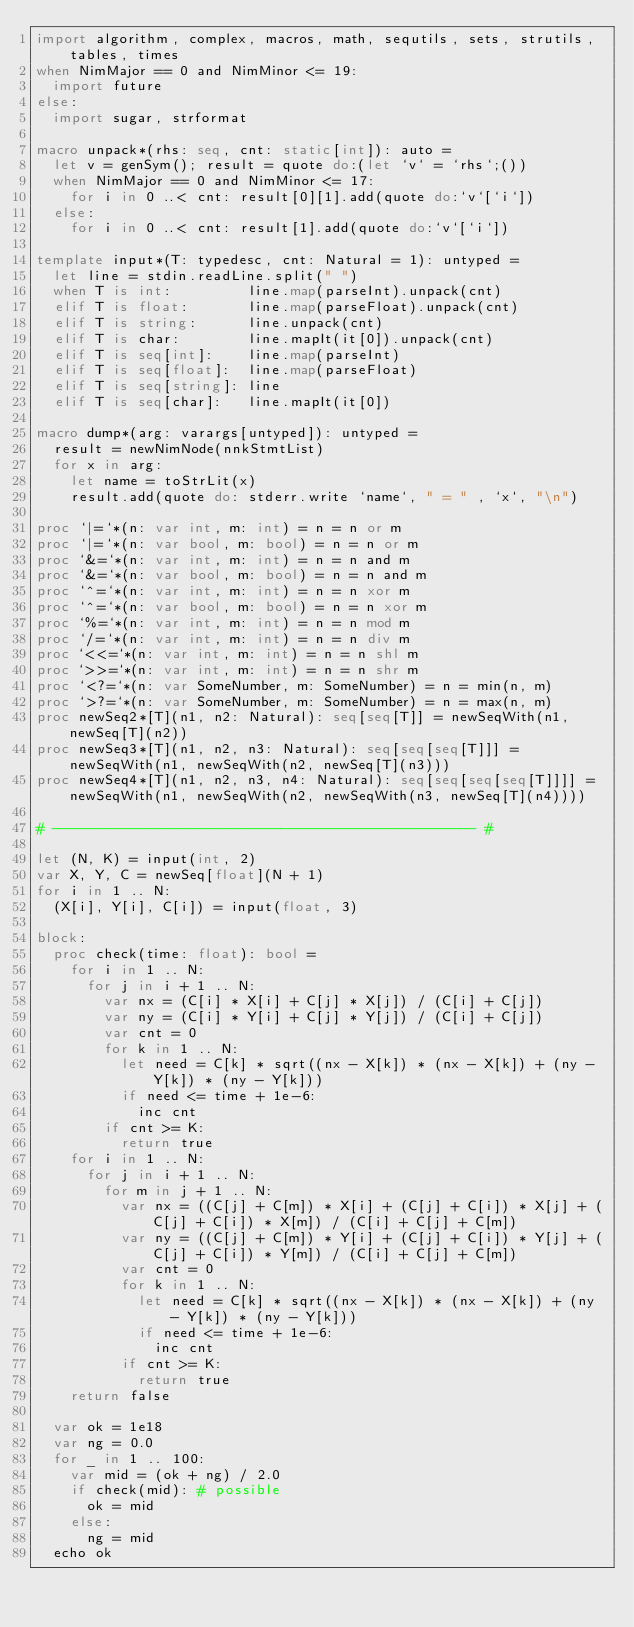Convert code to text. <code><loc_0><loc_0><loc_500><loc_500><_Nim_>import algorithm, complex, macros, math, sequtils, sets, strutils, tables, times
when NimMajor == 0 and NimMinor <= 19:
  import future
else:
  import sugar, strformat

macro unpack*(rhs: seq, cnt: static[int]): auto =
  let v = genSym(); result = quote do:(let `v` = `rhs`;())
  when NimMajor == 0 and NimMinor <= 17:
    for i in 0 ..< cnt: result[0][1].add(quote do:`v`[`i`])
  else:
    for i in 0 ..< cnt: result[1].add(quote do:`v`[`i`])

template input*(T: typedesc, cnt: Natural = 1): untyped =
  let line = stdin.readLine.split(" ")
  when T is int:         line.map(parseInt).unpack(cnt)
  elif T is float:       line.map(parseFloat).unpack(cnt)
  elif T is string:      line.unpack(cnt)
  elif T is char:        line.mapIt(it[0]).unpack(cnt)
  elif T is seq[int]:    line.map(parseInt)
  elif T is seq[float]:  line.map(parseFloat)
  elif T is seq[string]: line
  elif T is seq[char]:   line.mapIt(it[0])

macro dump*(arg: varargs[untyped]): untyped =
  result = newNimNode(nnkStmtList)
  for x in arg:
    let name = toStrLit(x)
    result.add(quote do: stderr.write `name`, " = " , `x`, "\n")

proc `|=`*(n: var int, m: int) = n = n or m
proc `|=`*(n: var bool, m: bool) = n = n or m
proc `&=`*(n: var int, m: int) = n = n and m
proc `&=`*(n: var bool, m: bool) = n = n and m
proc `^=`*(n: var int, m: int) = n = n xor m
proc `^=`*(n: var bool, m: bool) = n = n xor m
proc `%=`*(n: var int, m: int) = n = n mod m
proc `/=`*(n: var int, m: int) = n = n div m
proc `<<=`*(n: var int, m: int) = n = n shl m
proc `>>=`*(n: var int, m: int) = n = n shr m
proc `<?=`*(n: var SomeNumber, m: SomeNumber) = n = min(n, m)
proc `>?=`*(n: var SomeNumber, m: SomeNumber) = n = max(n, m)
proc newSeq2*[T](n1, n2: Natural): seq[seq[T]] = newSeqWith(n1, newSeq[T](n2))
proc newSeq3*[T](n1, n2, n3: Natural): seq[seq[seq[T]]] = newSeqWith(n1, newSeqWith(n2, newSeq[T](n3)))
proc newSeq4*[T](n1, n2, n3, n4: Natural): seq[seq[seq[seq[T]]]] = newSeqWith(n1, newSeqWith(n2, newSeqWith(n3, newSeq[T](n4))))

# -------------------------------------------------- #

let (N, K) = input(int, 2)
var X, Y, C = newSeq[float](N + 1)
for i in 1 .. N:
  (X[i], Y[i], C[i]) = input(float, 3)

block:
  proc check(time: float): bool =
    for i in 1 .. N:
      for j in i + 1 .. N:
        var nx = (C[i] * X[i] + C[j] * X[j]) / (C[i] + C[j])
        var ny = (C[i] * Y[i] + C[j] * Y[j]) / (C[i] + C[j])
        var cnt = 0
        for k in 1 .. N:
          let need = C[k] * sqrt((nx - X[k]) * (nx - X[k]) + (ny - Y[k]) * (ny - Y[k]))
          if need <= time + 1e-6:
            inc cnt
        if cnt >= K:
          return true
    for i in 1 .. N:
      for j in i + 1 .. N:
        for m in j + 1 .. N:
          var nx = ((C[j] + C[m]) * X[i] + (C[j] + C[i]) * X[j] + (C[j] + C[i]) * X[m]) / (C[i] + C[j] + C[m])
          var ny = ((C[j] + C[m]) * Y[i] + (C[j] + C[i]) * Y[j] + (C[j] + C[i]) * Y[m]) / (C[i] + C[j] + C[m])
          var cnt = 0
          for k in 1 .. N:
            let need = C[k] * sqrt((nx - X[k]) * (nx - X[k]) + (ny - Y[k]) * (ny - Y[k]))
            if need <= time + 1e-6:
              inc cnt
          if cnt >= K:
            return true
    return false

  var ok = 1e18
  var ng = 0.0
  for _ in 1 .. 100:
    var mid = (ok + ng) / 2.0
    if check(mid): # possible
      ok = mid
    else:
      ng = mid
  echo ok
</code> 